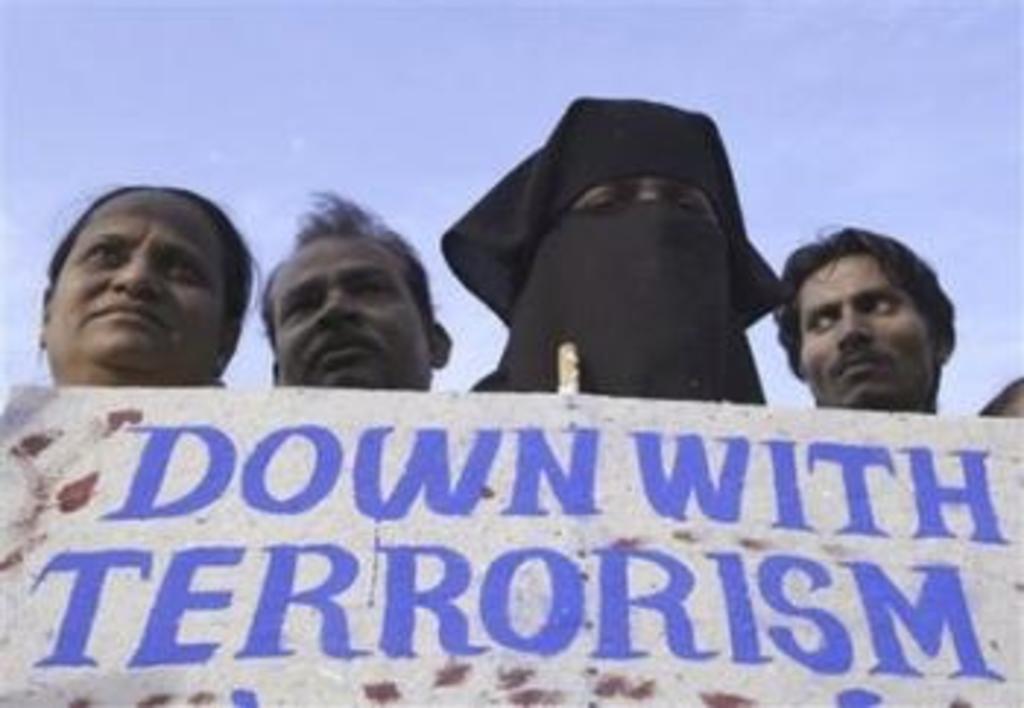Describe this image in one or two sentences. In the image two women and men standing behind a banner and above its sky. 